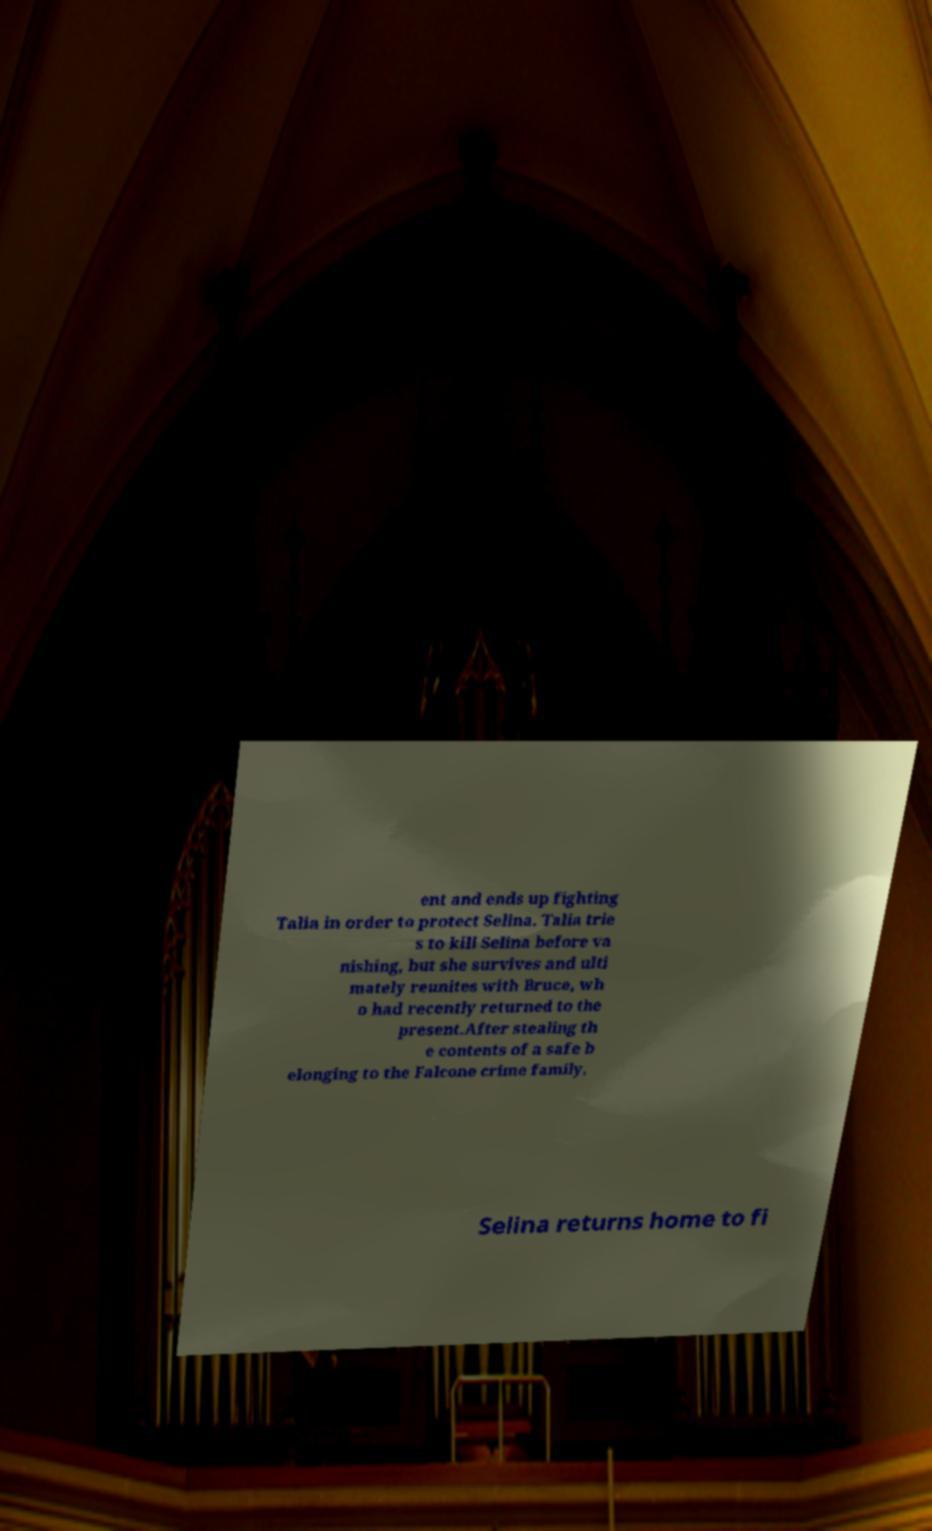I need the written content from this picture converted into text. Can you do that? ent and ends up fighting Talia in order to protect Selina. Talia trie s to kill Selina before va nishing, but she survives and ulti mately reunites with Bruce, wh o had recently returned to the present.After stealing th e contents of a safe b elonging to the Falcone crime family, Selina returns home to fi 